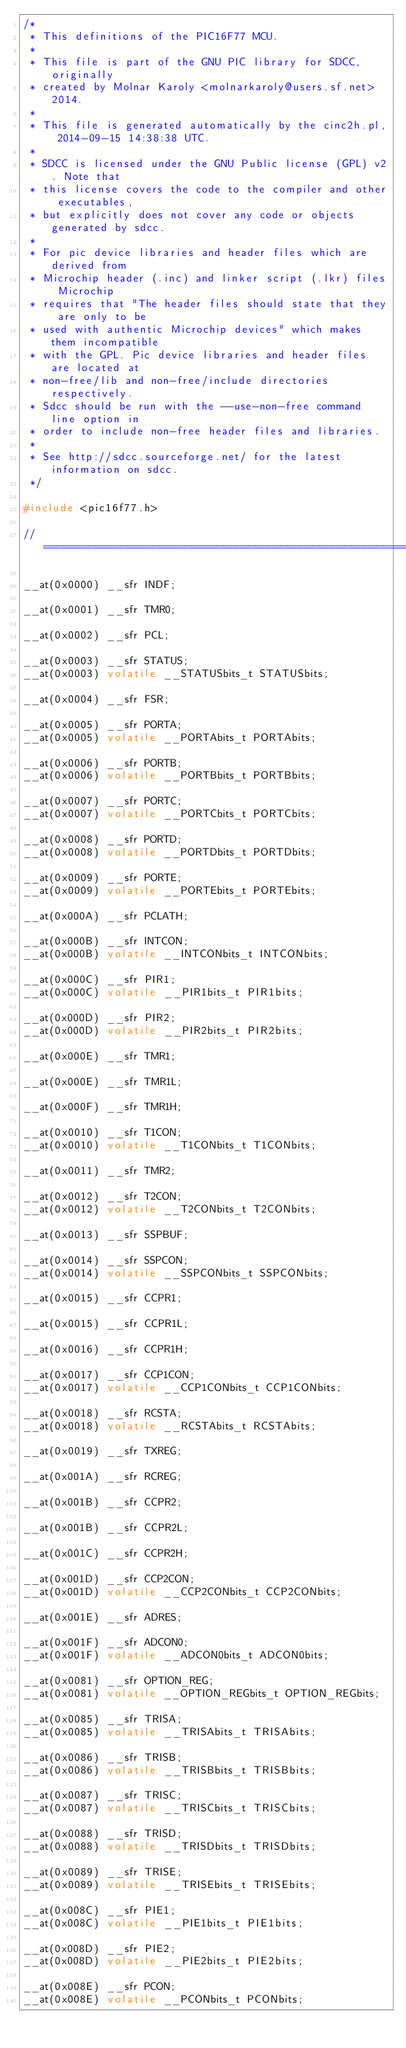<code> <loc_0><loc_0><loc_500><loc_500><_C_>/*
 * This definitions of the PIC16F77 MCU.
 *
 * This file is part of the GNU PIC library for SDCC, originally
 * created by Molnar Karoly <molnarkaroly@users.sf.net> 2014.
 *
 * This file is generated automatically by the cinc2h.pl, 2014-09-15 14:38:38 UTC.
 *
 * SDCC is licensed under the GNU Public license (GPL) v2. Note that
 * this license covers the code to the compiler and other executables,
 * but explicitly does not cover any code or objects generated by sdcc.
 *
 * For pic device libraries and header files which are derived from
 * Microchip header (.inc) and linker script (.lkr) files Microchip
 * requires that "The header files should state that they are only to be
 * used with authentic Microchip devices" which makes them incompatible
 * with the GPL. Pic device libraries and header files are located at
 * non-free/lib and non-free/include directories respectively.
 * Sdcc should be run with the --use-non-free command line option in
 * order to include non-free header files and libraries.
 *
 * See http://sdcc.sourceforge.net/ for the latest information on sdcc.
 */

#include <pic16f77.h>

//==============================================================================

__at(0x0000) __sfr INDF;

__at(0x0001) __sfr TMR0;

__at(0x0002) __sfr PCL;

__at(0x0003) __sfr STATUS;
__at(0x0003) volatile __STATUSbits_t STATUSbits;

__at(0x0004) __sfr FSR;

__at(0x0005) __sfr PORTA;
__at(0x0005) volatile __PORTAbits_t PORTAbits;

__at(0x0006) __sfr PORTB;
__at(0x0006) volatile __PORTBbits_t PORTBbits;

__at(0x0007) __sfr PORTC;
__at(0x0007) volatile __PORTCbits_t PORTCbits;

__at(0x0008) __sfr PORTD;
__at(0x0008) volatile __PORTDbits_t PORTDbits;

__at(0x0009) __sfr PORTE;
__at(0x0009) volatile __PORTEbits_t PORTEbits;

__at(0x000A) __sfr PCLATH;

__at(0x000B) __sfr INTCON;
__at(0x000B) volatile __INTCONbits_t INTCONbits;

__at(0x000C) __sfr PIR1;
__at(0x000C) volatile __PIR1bits_t PIR1bits;

__at(0x000D) __sfr PIR2;
__at(0x000D) volatile __PIR2bits_t PIR2bits;

__at(0x000E) __sfr TMR1;

__at(0x000E) __sfr TMR1L;

__at(0x000F) __sfr TMR1H;

__at(0x0010) __sfr T1CON;
__at(0x0010) volatile __T1CONbits_t T1CONbits;

__at(0x0011) __sfr TMR2;

__at(0x0012) __sfr T2CON;
__at(0x0012) volatile __T2CONbits_t T2CONbits;

__at(0x0013) __sfr SSPBUF;

__at(0x0014) __sfr SSPCON;
__at(0x0014) volatile __SSPCONbits_t SSPCONbits;

__at(0x0015) __sfr CCPR1;

__at(0x0015) __sfr CCPR1L;

__at(0x0016) __sfr CCPR1H;

__at(0x0017) __sfr CCP1CON;
__at(0x0017) volatile __CCP1CONbits_t CCP1CONbits;

__at(0x0018) __sfr RCSTA;
__at(0x0018) volatile __RCSTAbits_t RCSTAbits;

__at(0x0019) __sfr TXREG;

__at(0x001A) __sfr RCREG;

__at(0x001B) __sfr CCPR2;

__at(0x001B) __sfr CCPR2L;

__at(0x001C) __sfr CCPR2H;

__at(0x001D) __sfr CCP2CON;
__at(0x001D) volatile __CCP2CONbits_t CCP2CONbits;

__at(0x001E) __sfr ADRES;

__at(0x001F) __sfr ADCON0;
__at(0x001F) volatile __ADCON0bits_t ADCON0bits;

__at(0x0081) __sfr OPTION_REG;
__at(0x0081) volatile __OPTION_REGbits_t OPTION_REGbits;

__at(0x0085) __sfr TRISA;
__at(0x0085) volatile __TRISAbits_t TRISAbits;

__at(0x0086) __sfr TRISB;
__at(0x0086) volatile __TRISBbits_t TRISBbits;

__at(0x0087) __sfr TRISC;
__at(0x0087) volatile __TRISCbits_t TRISCbits;

__at(0x0088) __sfr TRISD;
__at(0x0088) volatile __TRISDbits_t TRISDbits;

__at(0x0089) __sfr TRISE;
__at(0x0089) volatile __TRISEbits_t TRISEbits;

__at(0x008C) __sfr PIE1;
__at(0x008C) volatile __PIE1bits_t PIE1bits;

__at(0x008D) __sfr PIE2;
__at(0x008D) volatile __PIE2bits_t PIE2bits;

__at(0x008E) __sfr PCON;
__at(0x008E) volatile __PCONbits_t PCONbits;
</code> 